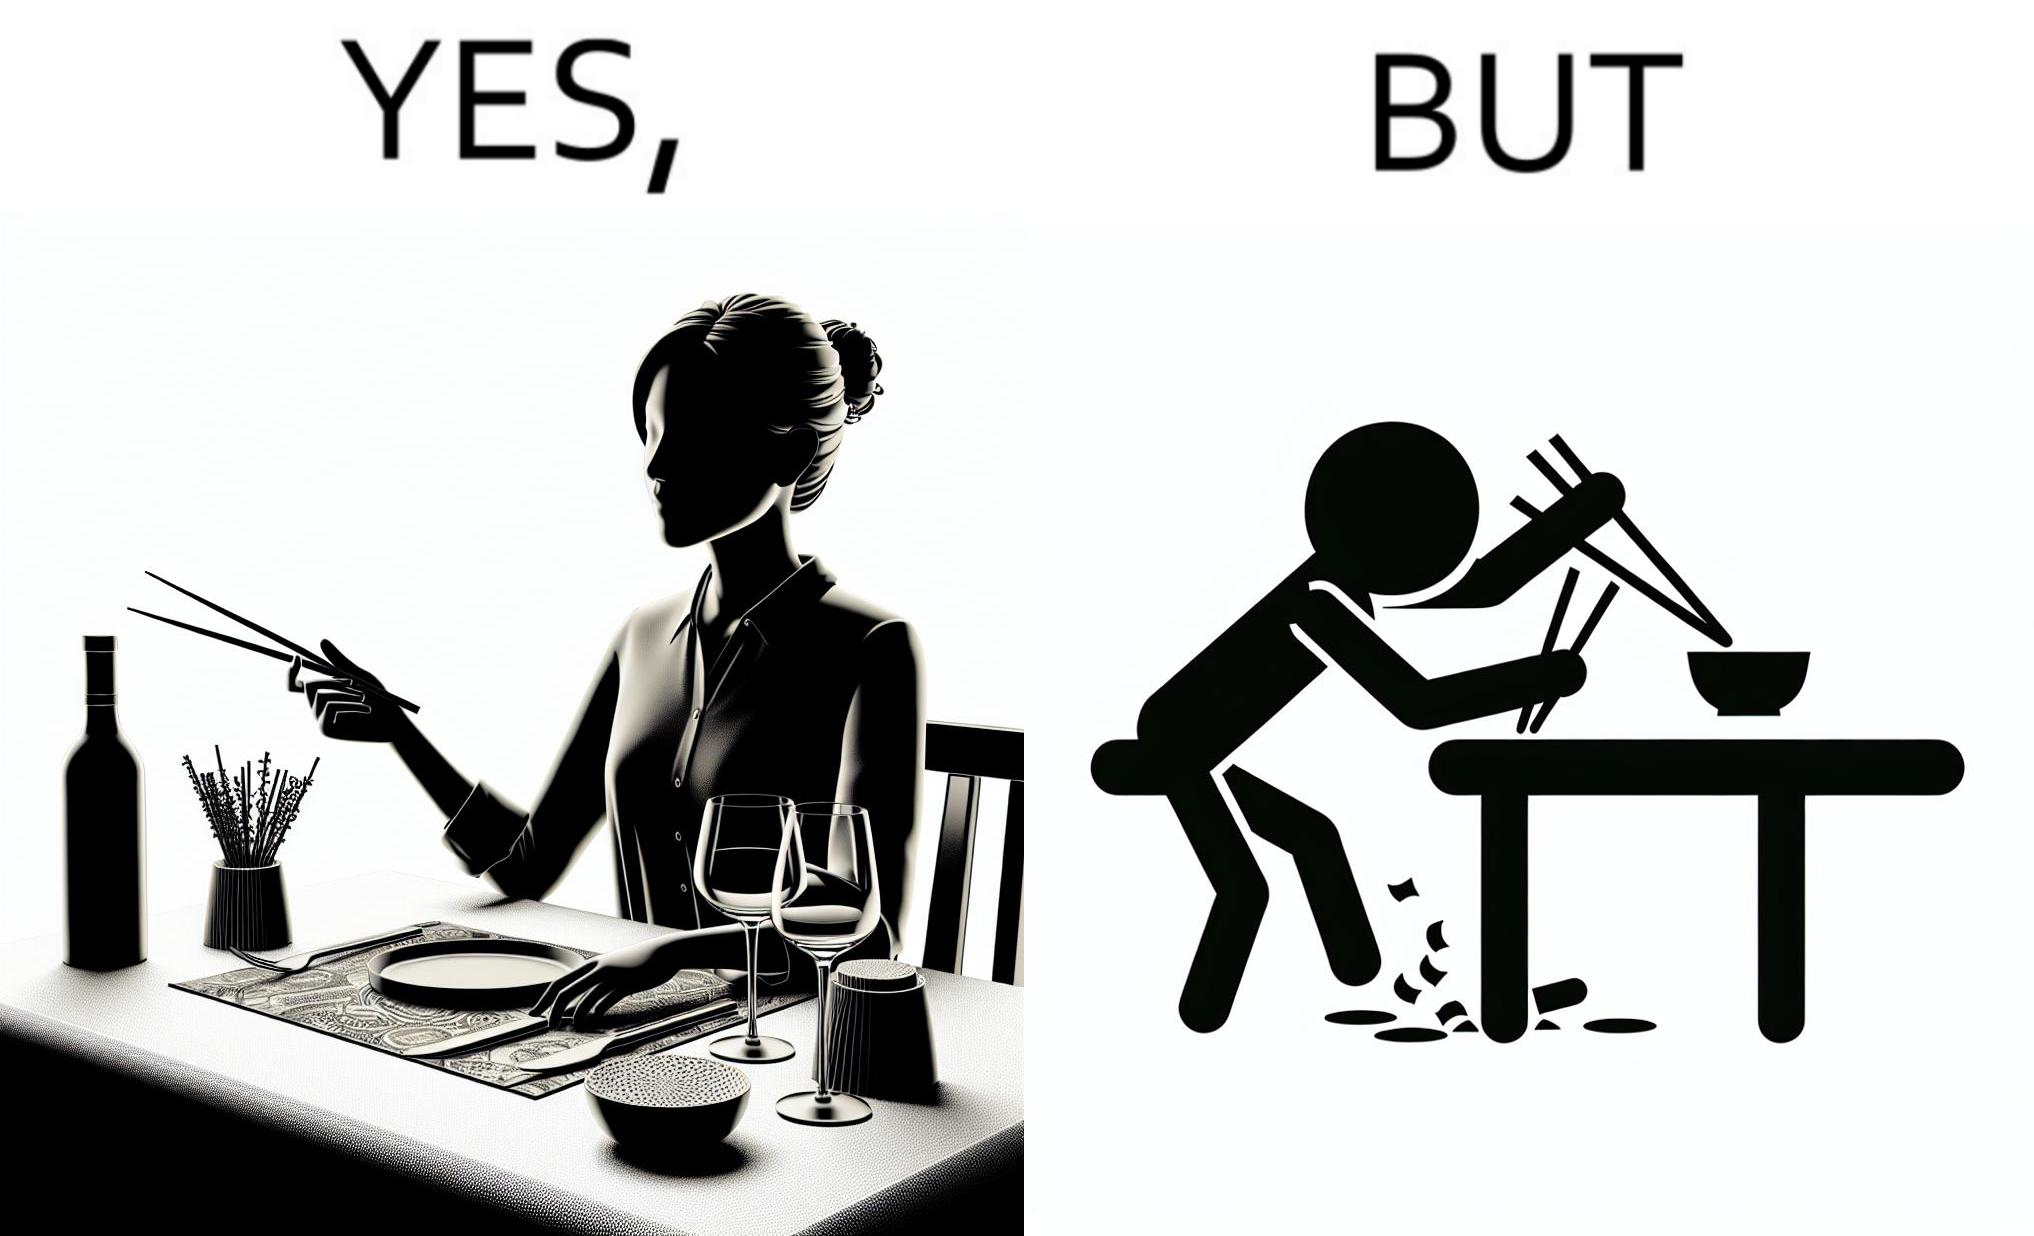Explain why this image is satirical. The image is satirical because even thought the woman is not able to eat food with chopstick properly, she chooses it over fork and knife to look sophisticaed. 